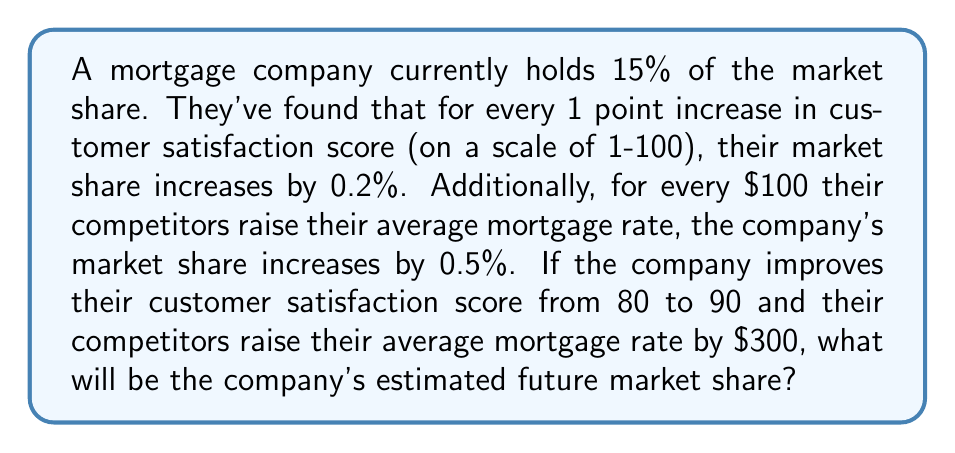Can you answer this question? Let's approach this step-by-step:

1) First, let's define our variables:
   $x$ = current market share
   $y$ = increase due to customer satisfaction
   $z$ = increase due to competitor pricing
   $f$ = final market share

2) We know the current market share: $x = 15\%$

3) Calculate the increase due to customer satisfaction:
   - The score increased by 10 points (90 - 80)
   - Each point increases share by 0.2%
   - $y = 10 \times 0.2\% = 2\%$

4) Calculate the increase due to competitor pricing:
   - Competitors raised rates by $300
   - Every $100 increase results in 0.5% increase
   - $z = 3 \times 0.5\% = 1.5\%$

5) The final market share will be the sum of these components:
   $$f = x + y + z$$
   $$f = 15\% + 2\% + 1.5\%$$
   $$f = 18.5\%$$

Therefore, the company's estimated future market share will be 18.5%.
Answer: 18.5% 